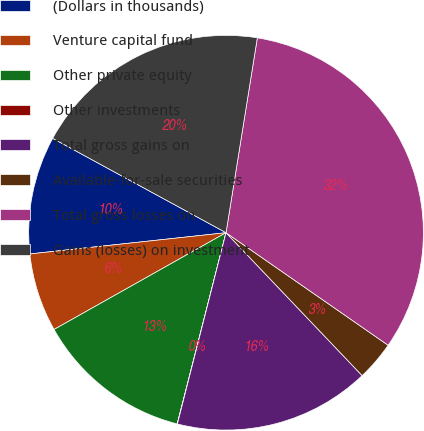<chart> <loc_0><loc_0><loc_500><loc_500><pie_chart><fcel>(Dollars in thousands)<fcel>Venture capital fund<fcel>Other private equity<fcel>Other investments<fcel>Total gross gains on<fcel>Available-for-sale securities<fcel>Total gross losses on<fcel>Gains (losses) on investment<nl><fcel>9.65%<fcel>6.44%<fcel>12.86%<fcel>0.02%<fcel>16.07%<fcel>3.23%<fcel>32.12%<fcel>19.6%<nl></chart> 